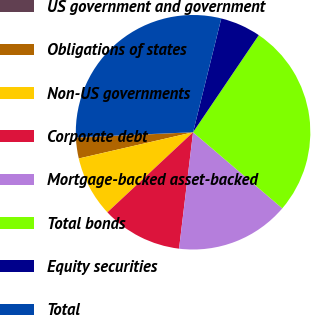Convert chart to OTSL. <chart><loc_0><loc_0><loc_500><loc_500><pie_chart><fcel>US government and government<fcel>Obligations of states<fcel>Non-US governments<fcel>Corporate debt<fcel>Mortgage-backed asset-backed<fcel>Total bonds<fcel>Equity securities<fcel>Total<nl><fcel>0.08%<fcel>2.84%<fcel>8.37%<fcel>11.13%<fcel>15.67%<fcel>26.77%<fcel>5.6%<fcel>29.54%<nl></chart> 